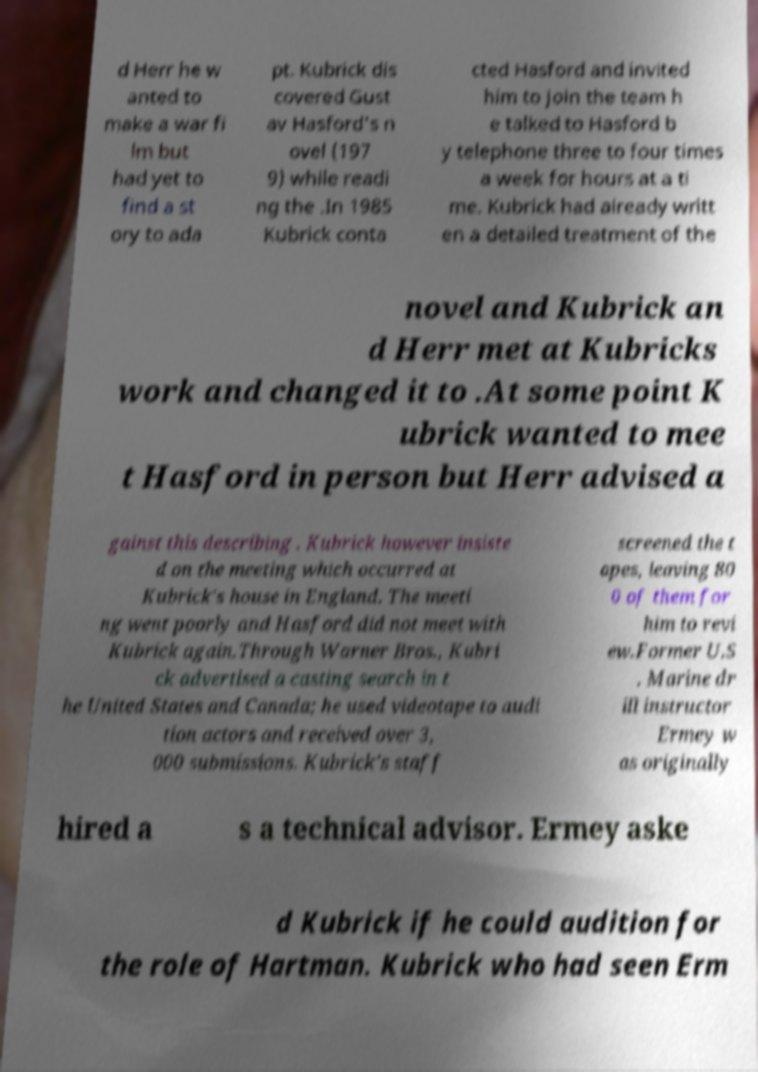Can you accurately transcribe the text from the provided image for me? d Herr he w anted to make a war fi lm but had yet to find a st ory to ada pt. Kubrick dis covered Gust av Hasford's n ovel (197 9) while readi ng the .In 1985 Kubrick conta cted Hasford and invited him to join the team h e talked to Hasford b y telephone three to four times a week for hours at a ti me. Kubrick had already writt en a detailed treatment of the novel and Kubrick an d Herr met at Kubricks work and changed it to .At some point K ubrick wanted to mee t Hasford in person but Herr advised a gainst this describing . Kubrick however insiste d on the meeting which occurred at Kubrick's house in England. The meeti ng went poorly and Hasford did not meet with Kubrick again.Through Warner Bros., Kubri ck advertised a casting search in t he United States and Canada; he used videotape to audi tion actors and received over 3, 000 submissions. Kubrick's staff screened the t apes, leaving 80 0 of them for him to revi ew.Former U.S . Marine dr ill instructor Ermey w as originally hired a s a technical advisor. Ermey aske d Kubrick if he could audition for the role of Hartman. Kubrick who had seen Erm 